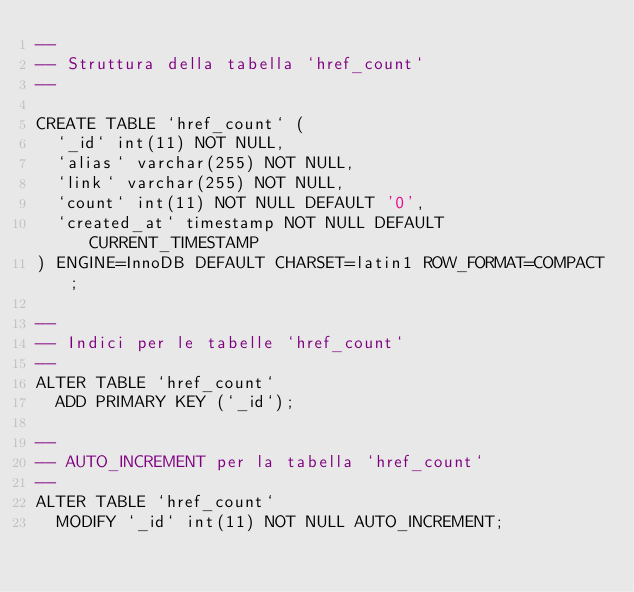Convert code to text. <code><loc_0><loc_0><loc_500><loc_500><_SQL_>--
-- Struttura della tabella `href_count`
--

CREATE TABLE `href_count` (
  `_id` int(11) NOT NULL,
  `alias` varchar(255) NOT NULL,
  `link` varchar(255) NOT NULL,
  `count` int(11) NOT NULL DEFAULT '0',
  `created_at` timestamp NOT NULL DEFAULT CURRENT_TIMESTAMP
) ENGINE=InnoDB DEFAULT CHARSET=latin1 ROW_FORMAT=COMPACT;

--
-- Indici per le tabelle `href_count`
--
ALTER TABLE `href_count`
  ADD PRIMARY KEY (`_id`);

--
-- AUTO_INCREMENT per la tabella `href_count`
--
ALTER TABLE `href_count`
  MODIFY `_id` int(11) NOT NULL AUTO_INCREMENT;</code> 